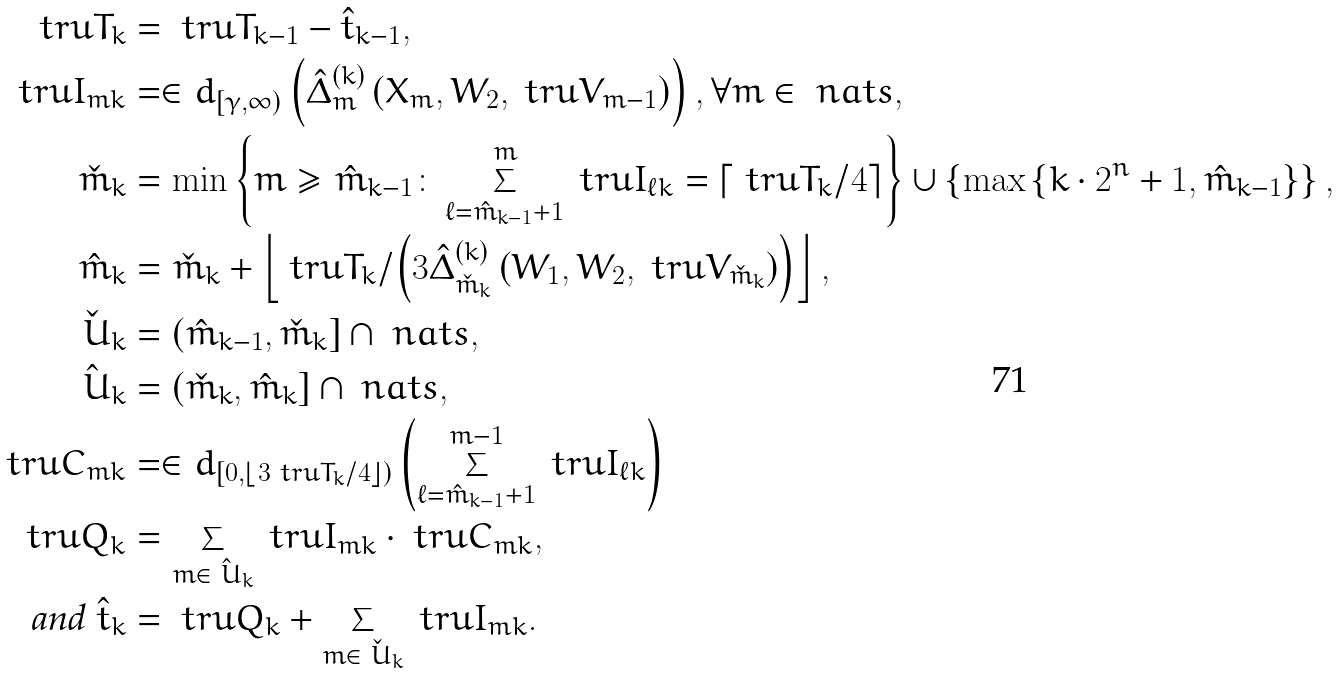<formula> <loc_0><loc_0><loc_500><loc_500>\ t r u T _ { k } & = \ t r u T _ { k - 1 } - \hat { t } _ { k - 1 } , \\ \ t r u I _ { m k } & = \in d _ { [ \gamma , \infty ) } \left ( \hat { \Delta } _ { m } ^ { ( k ) } \left ( X _ { m } , W _ { 2 } , \ t r u V _ { m - 1 } \right ) \right ) , \forall m \in \ n a t s , \\ \check { m } _ { k } & = \min \left \{ m \geq \hat { m } _ { k - 1 } \colon \sum _ { \ell = \hat { m } _ { k - 1 } + 1 } ^ { m } \ t r u I _ { \ell k } = \left \lceil \ t r u T _ { k } / 4 \right \rceil \right \} \cup \left \{ \max \left \{ k \cdot 2 ^ { n } + 1 , \hat { m } _ { k - 1 } \right \} \right \} , \\ \hat { m } _ { k } & = \check { m } _ { k } + \left \lfloor \ t r u T _ { k } / \left ( 3 \hat { \Delta } _ { \check { m } _ { k } } ^ { ( k ) } \left ( W _ { 1 } , W _ { 2 } , \ t r u V _ { \check { m } _ { k } } \right ) \right ) \right \rfloor , \\ \check { \ U } _ { k } & = ( \hat { m } _ { k - 1 } , \check { m } _ { k } ] \cap \ n a t s , \\ \hat { \ U } _ { k } & = ( \check { m } _ { k } , \hat { m } _ { k } ] \cap \ n a t s , \\ \ t r u C _ { m k } & = \in d _ { \left [ 0 , \left \lfloor 3 \ t r u T _ { k } / 4 \right \rfloor \right ) } \left ( \sum _ { \ell = \hat { m } _ { k - 1 } + 1 } ^ { m - 1 } \ t r u I _ { \ell k } \right ) \\ \ t r u Q _ { k } & = \sum _ { m \in \hat { \ U } _ { k } } \ t r u I _ { m k } \cdot \ t r u C _ { m k } , \\ \text {and } \hat { t } _ { k } & = \ t r u Q _ { k } + \sum _ { m \in \check { \ U } _ { k } } \ t r u I _ { m k } .</formula> 